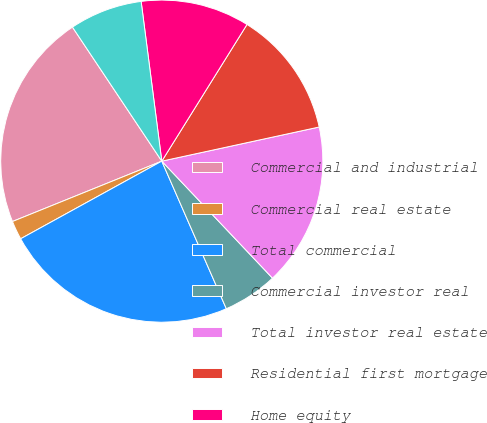<chart> <loc_0><loc_0><loc_500><loc_500><pie_chart><fcel>Commercial and industrial<fcel>Commercial real estate<fcel>Total commercial<fcel>Commercial investor real<fcel>Total investor real estate<fcel>Residential first mortgage<fcel>Home equity<fcel>Indirect-vehicles<nl><fcel>21.76%<fcel>1.89%<fcel>23.56%<fcel>5.5%<fcel>16.34%<fcel>12.73%<fcel>10.92%<fcel>7.31%<nl></chart> 